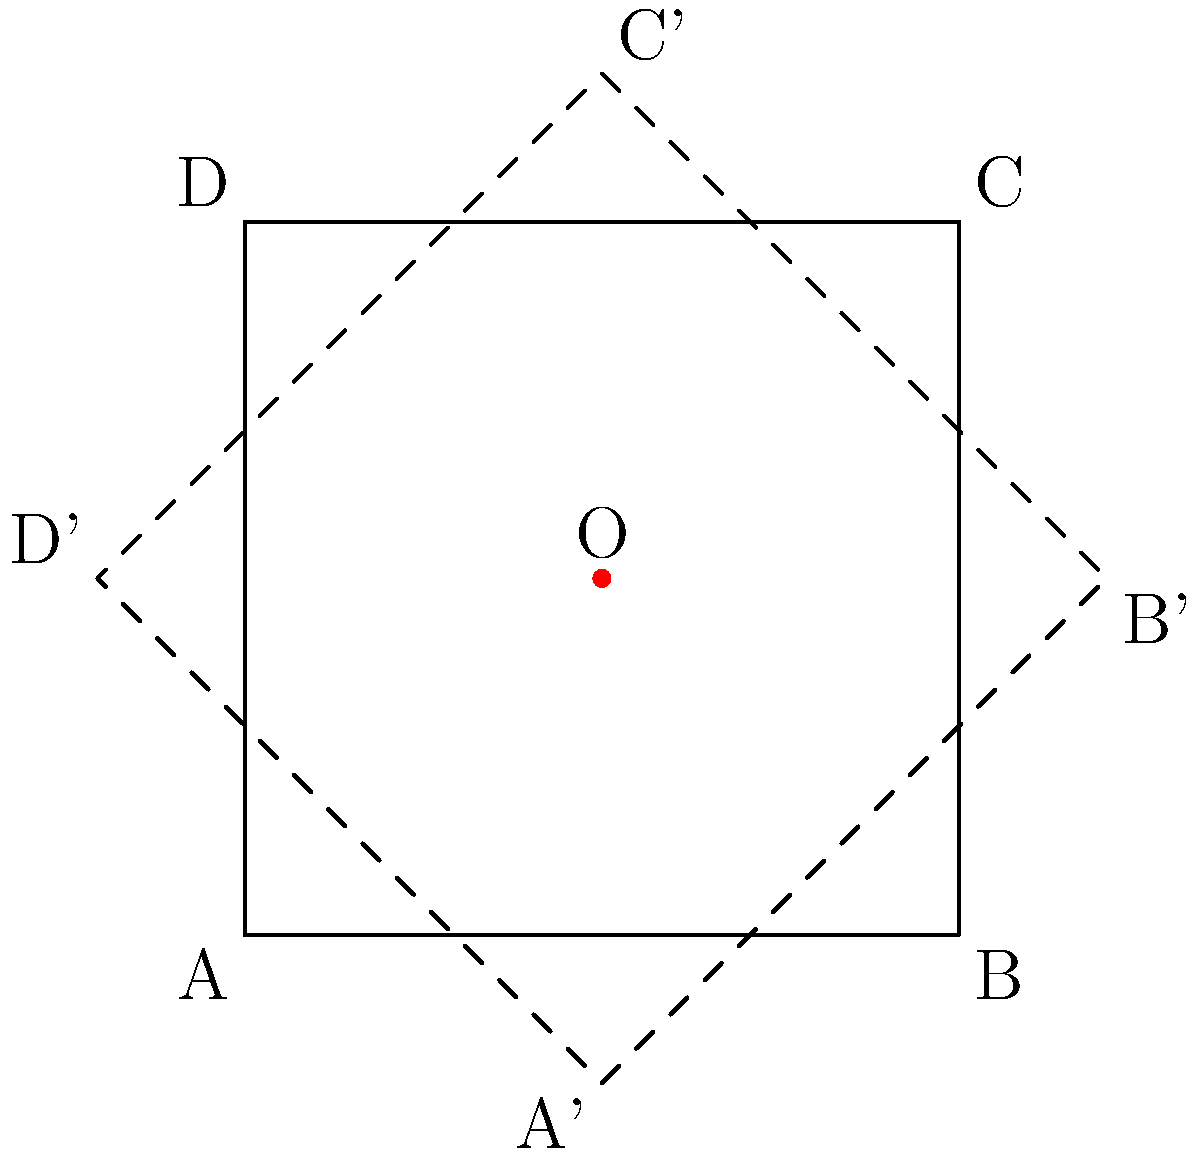In the spirit of promoting mathematical understanding across diverse fields, consider a square ABCD with side length 2 units and center O. If we rotate this square 45° around point O, how does this transformation affect the area of the square? Explain your reasoning, considering the implications of such geometric principles in policy-making and public understanding. Let's approach this step-by-step:

1) First, we need to understand what rotation means in geometry. Rotation is a rigid transformation, which means it preserves the shape and size of the object being rotated.

2) The key property of rigid transformations is that they preserve distances between points. This means that the length of each side of the square remains unchanged after rotation.

3) Since the side lengths remain the same, and the angles of the square are also preserved (it's still a square after rotation), we can conclude that the area of the square must also remain unchanged.

4) Mathematically, we can express this as follows:
   - Area before rotation: $A = s^2 = 2^2 = 4$ square units
   - Area after rotation: $A' = s^2 = 2^2 = 4$ square units

5) Therefore, $A = A'$, meaning the area is preserved under rotation.

This principle demonstrates that certain fundamental properties remain constant even as perspectives change, much like how core democratic values should persist regardless of political shifts. Understanding such invariances can be crucial in crafting policies that remain effective across different contexts or viewpoints.
Answer: The area remains unchanged at 4 square units. 